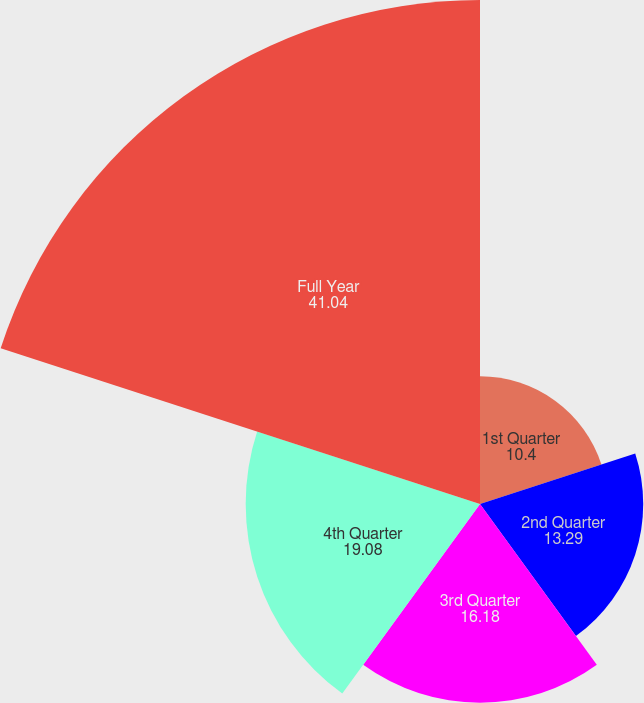Convert chart. <chart><loc_0><loc_0><loc_500><loc_500><pie_chart><fcel>1st Quarter<fcel>2nd Quarter<fcel>3rd Quarter<fcel>4th Quarter<fcel>Full Year<nl><fcel>10.4%<fcel>13.29%<fcel>16.18%<fcel>19.08%<fcel>41.04%<nl></chart> 